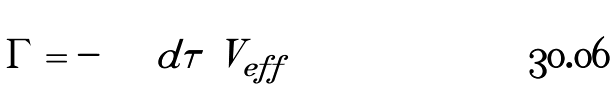<formula> <loc_0><loc_0><loc_500><loc_500>\Gamma = - \int d \tau \ V _ { e f f }</formula> 